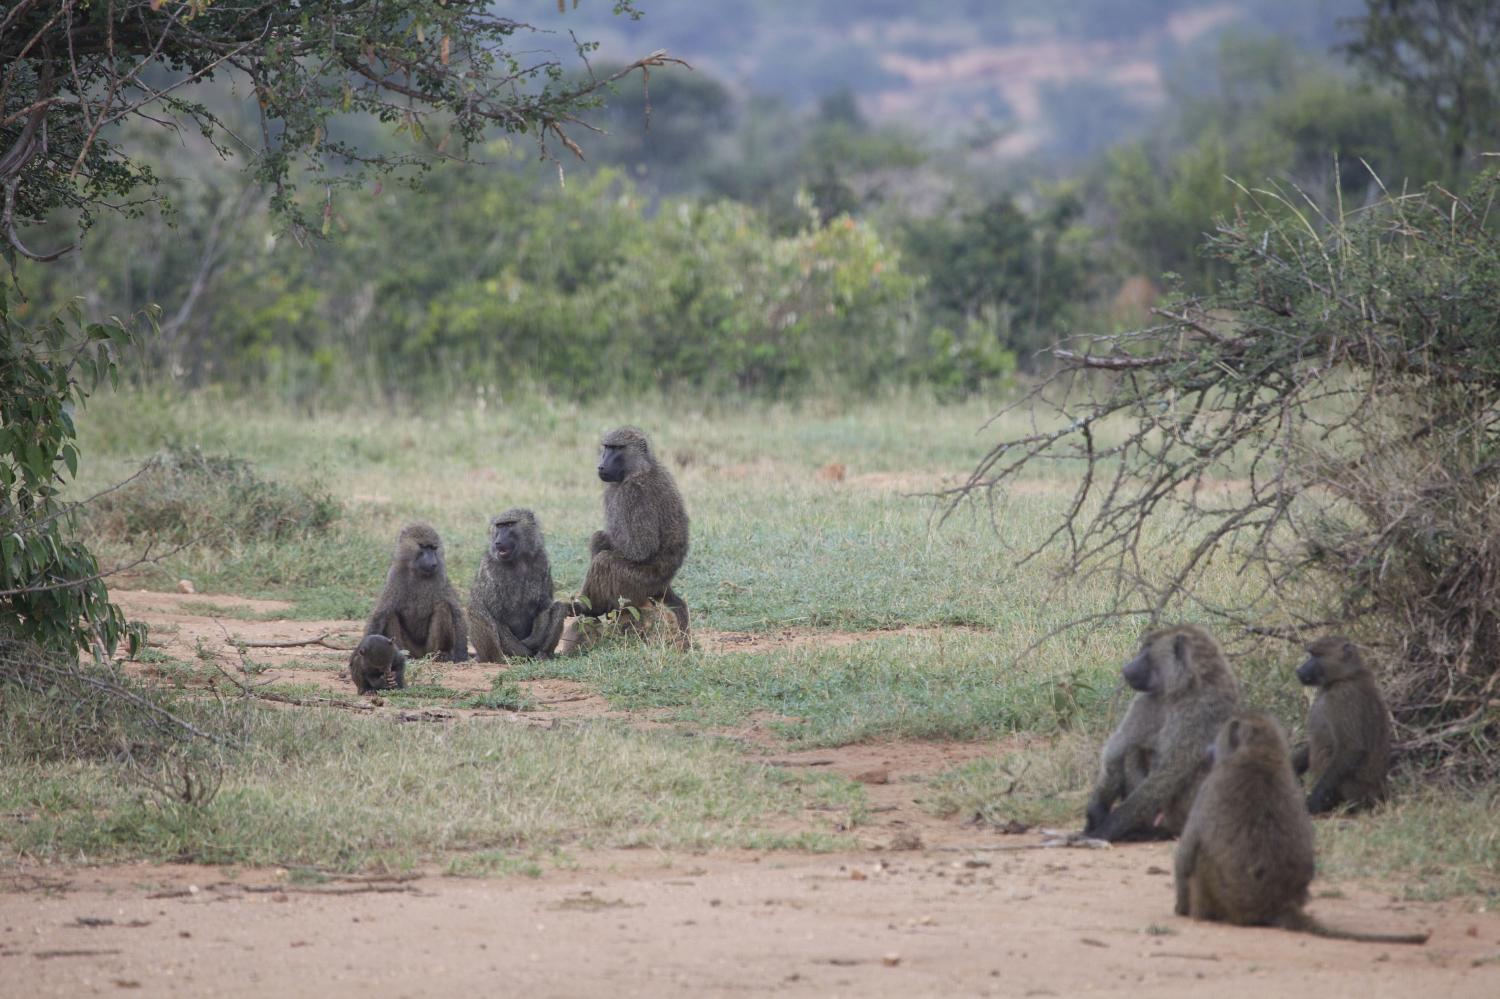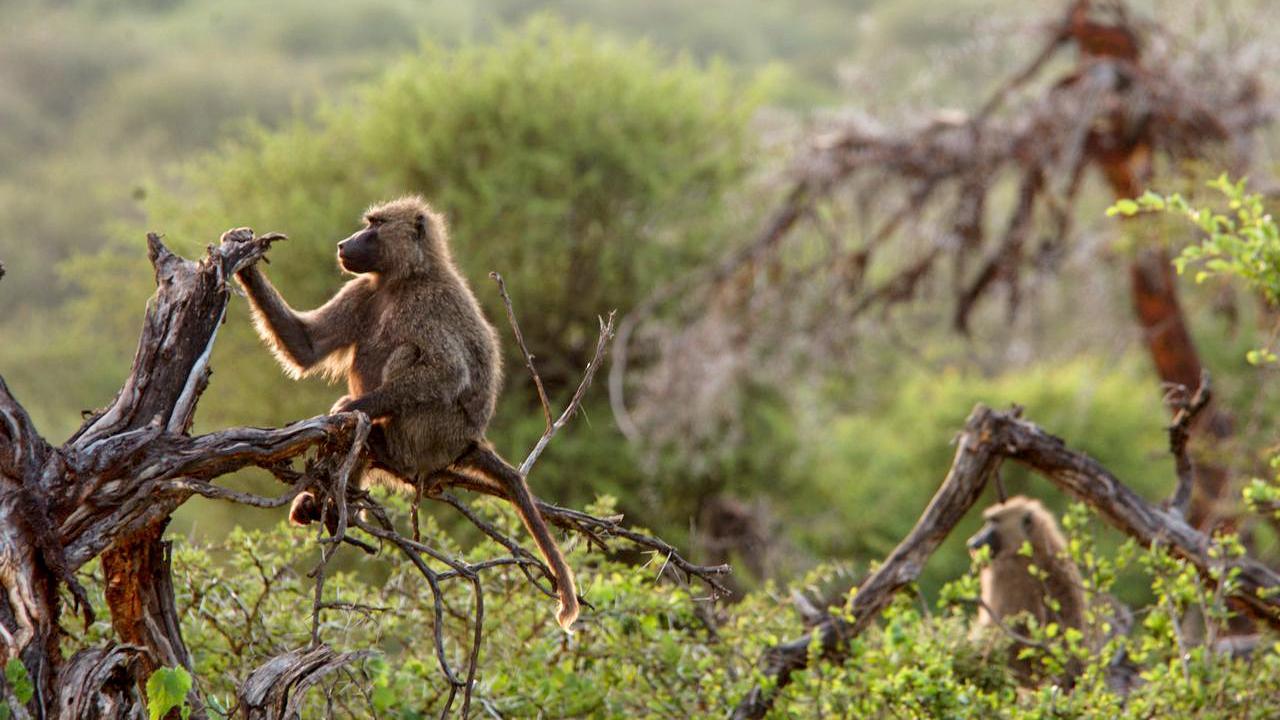The first image is the image on the left, the second image is the image on the right. For the images displayed, is the sentence "Some of the animals are in a dirt path." factually correct? Answer yes or no. Yes. The first image is the image on the left, the second image is the image on the right. Examine the images to the left and right. Is the description "An image shows baboons sitting in a patch of dirt near a tree." accurate? Answer yes or no. Yes. 